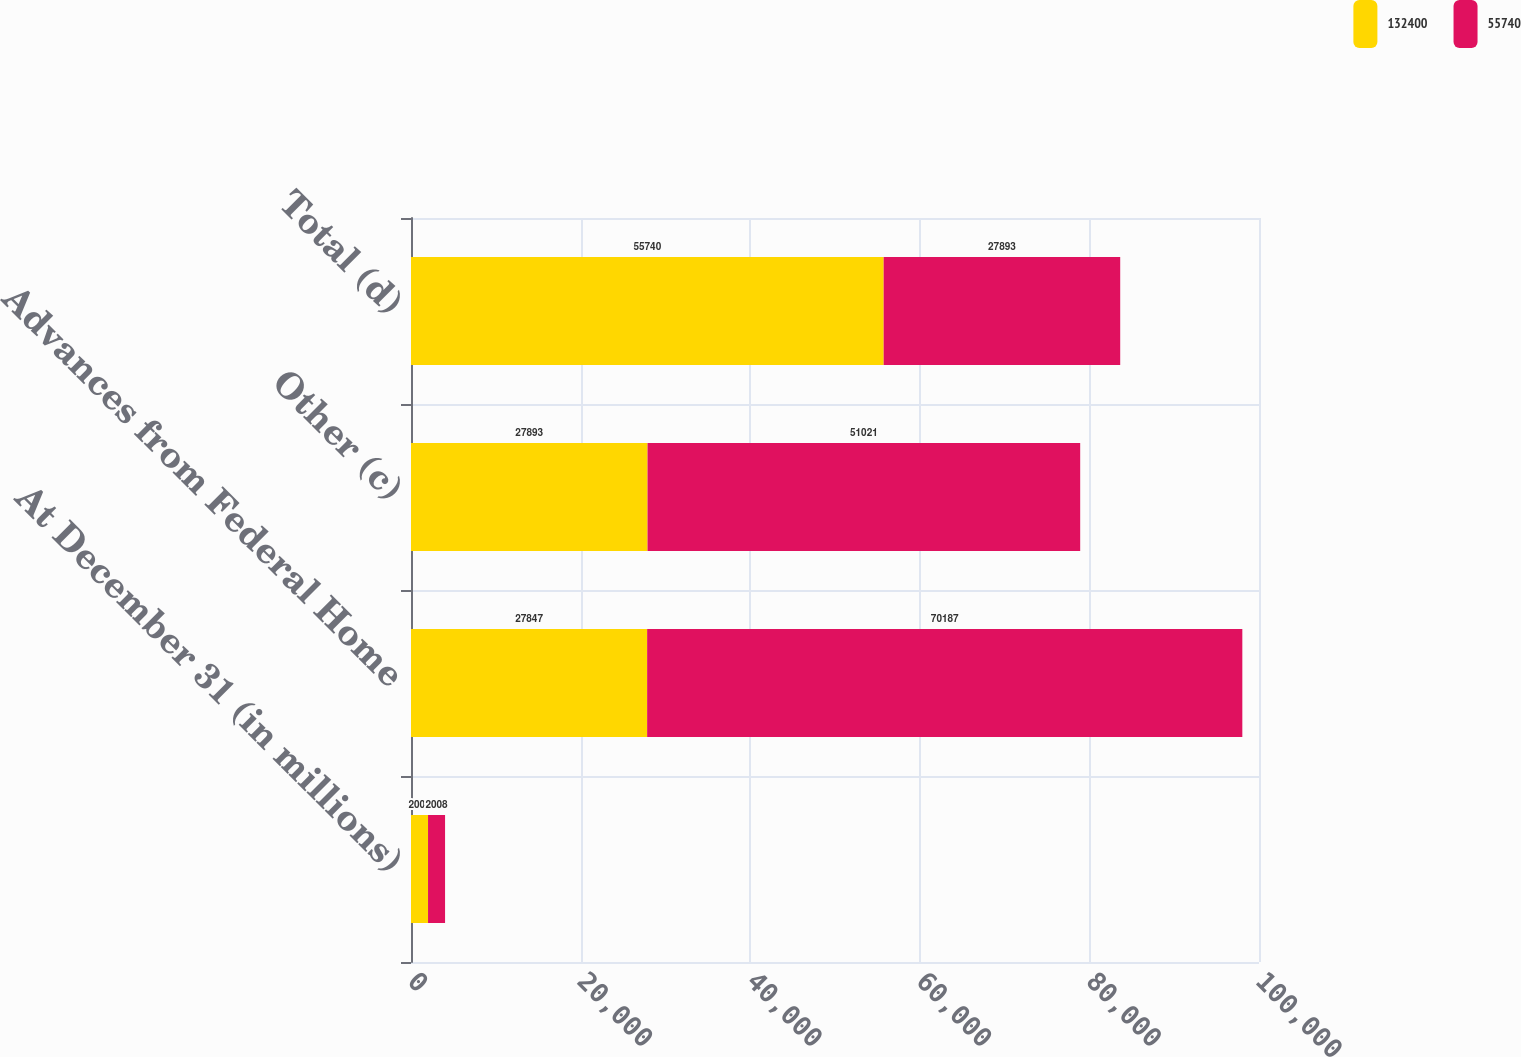Convert chart to OTSL. <chart><loc_0><loc_0><loc_500><loc_500><stacked_bar_chart><ecel><fcel>At December 31 (in millions)<fcel>Advances from Federal Home<fcel>Other (c)<fcel>Total (d)<nl><fcel>132400<fcel>2009<fcel>27847<fcel>27893<fcel>55740<nl><fcel>55740<fcel>2008<fcel>70187<fcel>51021<fcel>27893<nl></chart> 